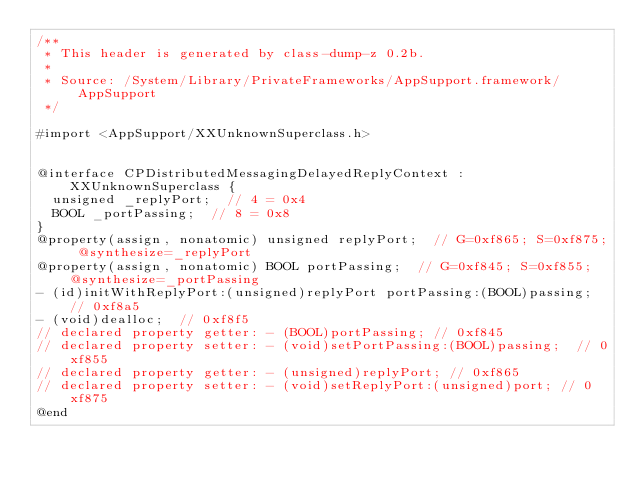<code> <loc_0><loc_0><loc_500><loc_500><_C_>/**
 * This header is generated by class-dump-z 0.2b.
 *
 * Source: /System/Library/PrivateFrameworks/AppSupport.framework/AppSupport
 */

#import <AppSupport/XXUnknownSuperclass.h>


@interface CPDistributedMessagingDelayedReplyContext : XXUnknownSuperclass {
	unsigned _replyPort;	// 4 = 0x4
	BOOL _portPassing;	// 8 = 0x8
}
@property(assign, nonatomic) unsigned replyPort;	// G=0xf865; S=0xf875; @synthesize=_replyPort
@property(assign, nonatomic) BOOL portPassing;	// G=0xf845; S=0xf855; @synthesize=_portPassing
- (id)initWithReplyPort:(unsigned)replyPort portPassing:(BOOL)passing;	// 0xf8a5
- (void)dealloc;	// 0xf8f5
// declared property getter: - (BOOL)portPassing;	// 0xf845
// declared property setter: - (void)setPortPassing:(BOOL)passing;	// 0xf855
// declared property getter: - (unsigned)replyPort;	// 0xf865
// declared property setter: - (void)setReplyPort:(unsigned)port;	// 0xf875
@end
</code> 